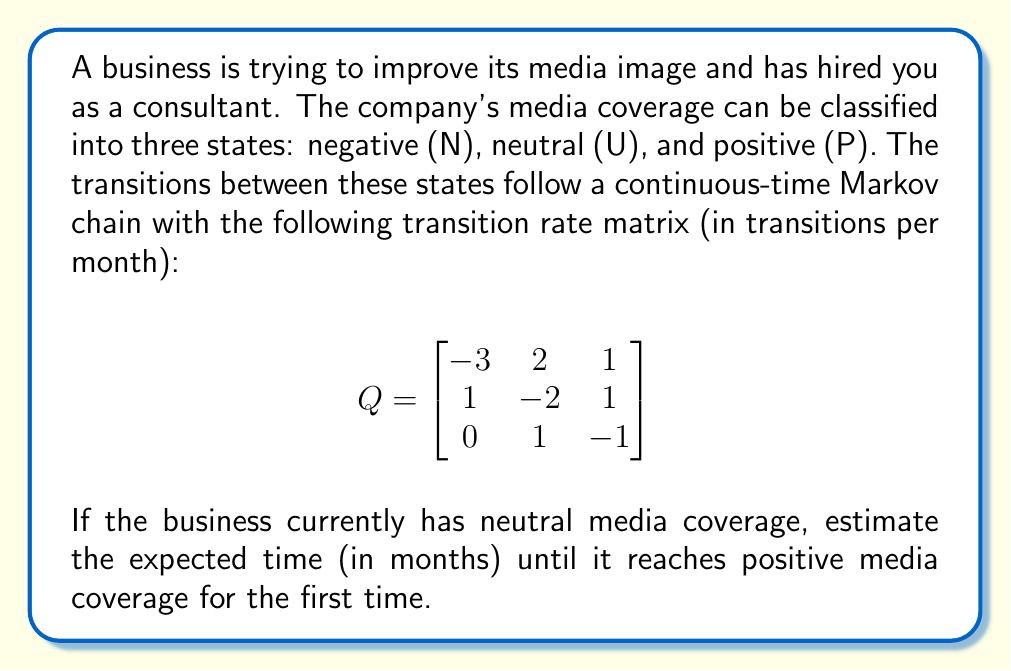Solve this math problem. To solve this problem, we need to use the concept of mean first passage times in continuous-time Markov chains. Let's follow these steps:

1) Let $m_{ij}$ be the mean first passage time from state $i$ to state $j$. We want to find $m_{UP}$, the mean time to go from neutral (U) to positive (P) coverage.

2) For a continuous-time Markov chain, the mean first passage times satisfy the following system of linear equations:

   $$m_{ij} = -\frac{1}{q_{ii}} + \sum_{k \neq j} \frac{q_{ik}}{q_{ii}}m_{kj}$$

   where $q_{ij}$ are the elements of the transition rate matrix $Q$.

3) In our case, we need to solve two equations:

   $$m_{NP} = -\frac{1}{q_{NN}} + \frac{q_{NU}}{q_{NN}}m_{UP}$$
   $$m_{UP} = -\frac{1}{q_{UU}} + \frac{q_{UN}}{q_{UU}}m_{NP}$$

4) Substituting the values from the given $Q$ matrix:

   $$m_{NP} = \frac{1}{3} + \frac{2}{3}m_{UP}$$
   $$m_{UP} = \frac{1}{2} + \frac{1}{2}m_{NP}$$

5) Now we have a system of two equations with two unknowns. Let's solve for $m_{UP}$:

   Substitute the first equation into the second:
   $$m_{UP} = \frac{1}{2} + \frac{1}{2}(\frac{1}{3} + \frac{2}{3}m_{UP})$$

6) Simplify:
   $$m_{UP} = \frac{1}{2} + \frac{1}{6} + \frac{1}{3}m_{UP}$$
   $$\frac{2}{3}m_{UP} = \frac{2}{3}$$
   $$m_{UP} = 1$$

Therefore, the expected time to reach positive media coverage from a neutral state is 1 month.
Answer: 1 month 